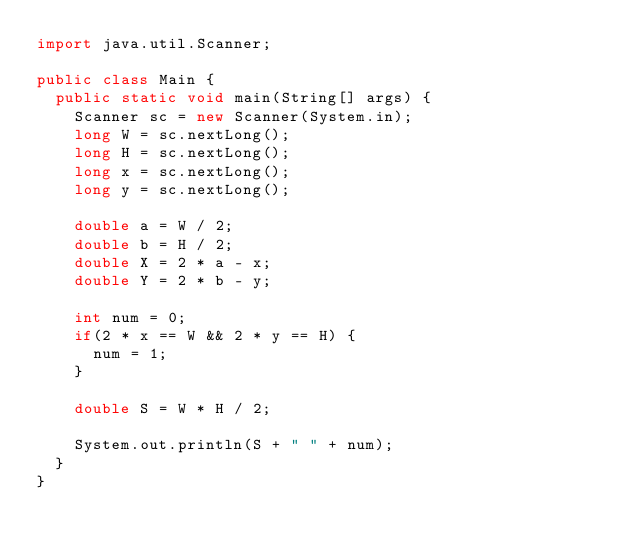<code> <loc_0><loc_0><loc_500><loc_500><_Java_>import java.util.Scanner;

public class Main {
	public static void main(String[] args) {
		Scanner sc = new Scanner(System.in);
		long W = sc.nextLong();
		long H = sc.nextLong();
		long x = sc.nextLong();
		long y = sc.nextLong();
		
		double a = W / 2;
		double b = H / 2;
		double X = 2 * a - x;
		double Y = 2 * b - y;
		
		int num = 0;
		if(2 * x == W && 2 * y == H) {
			num = 1;
		}
		
		double S = W * H / 2;
		
		System.out.println(S + " " + num);
	}
}
</code> 